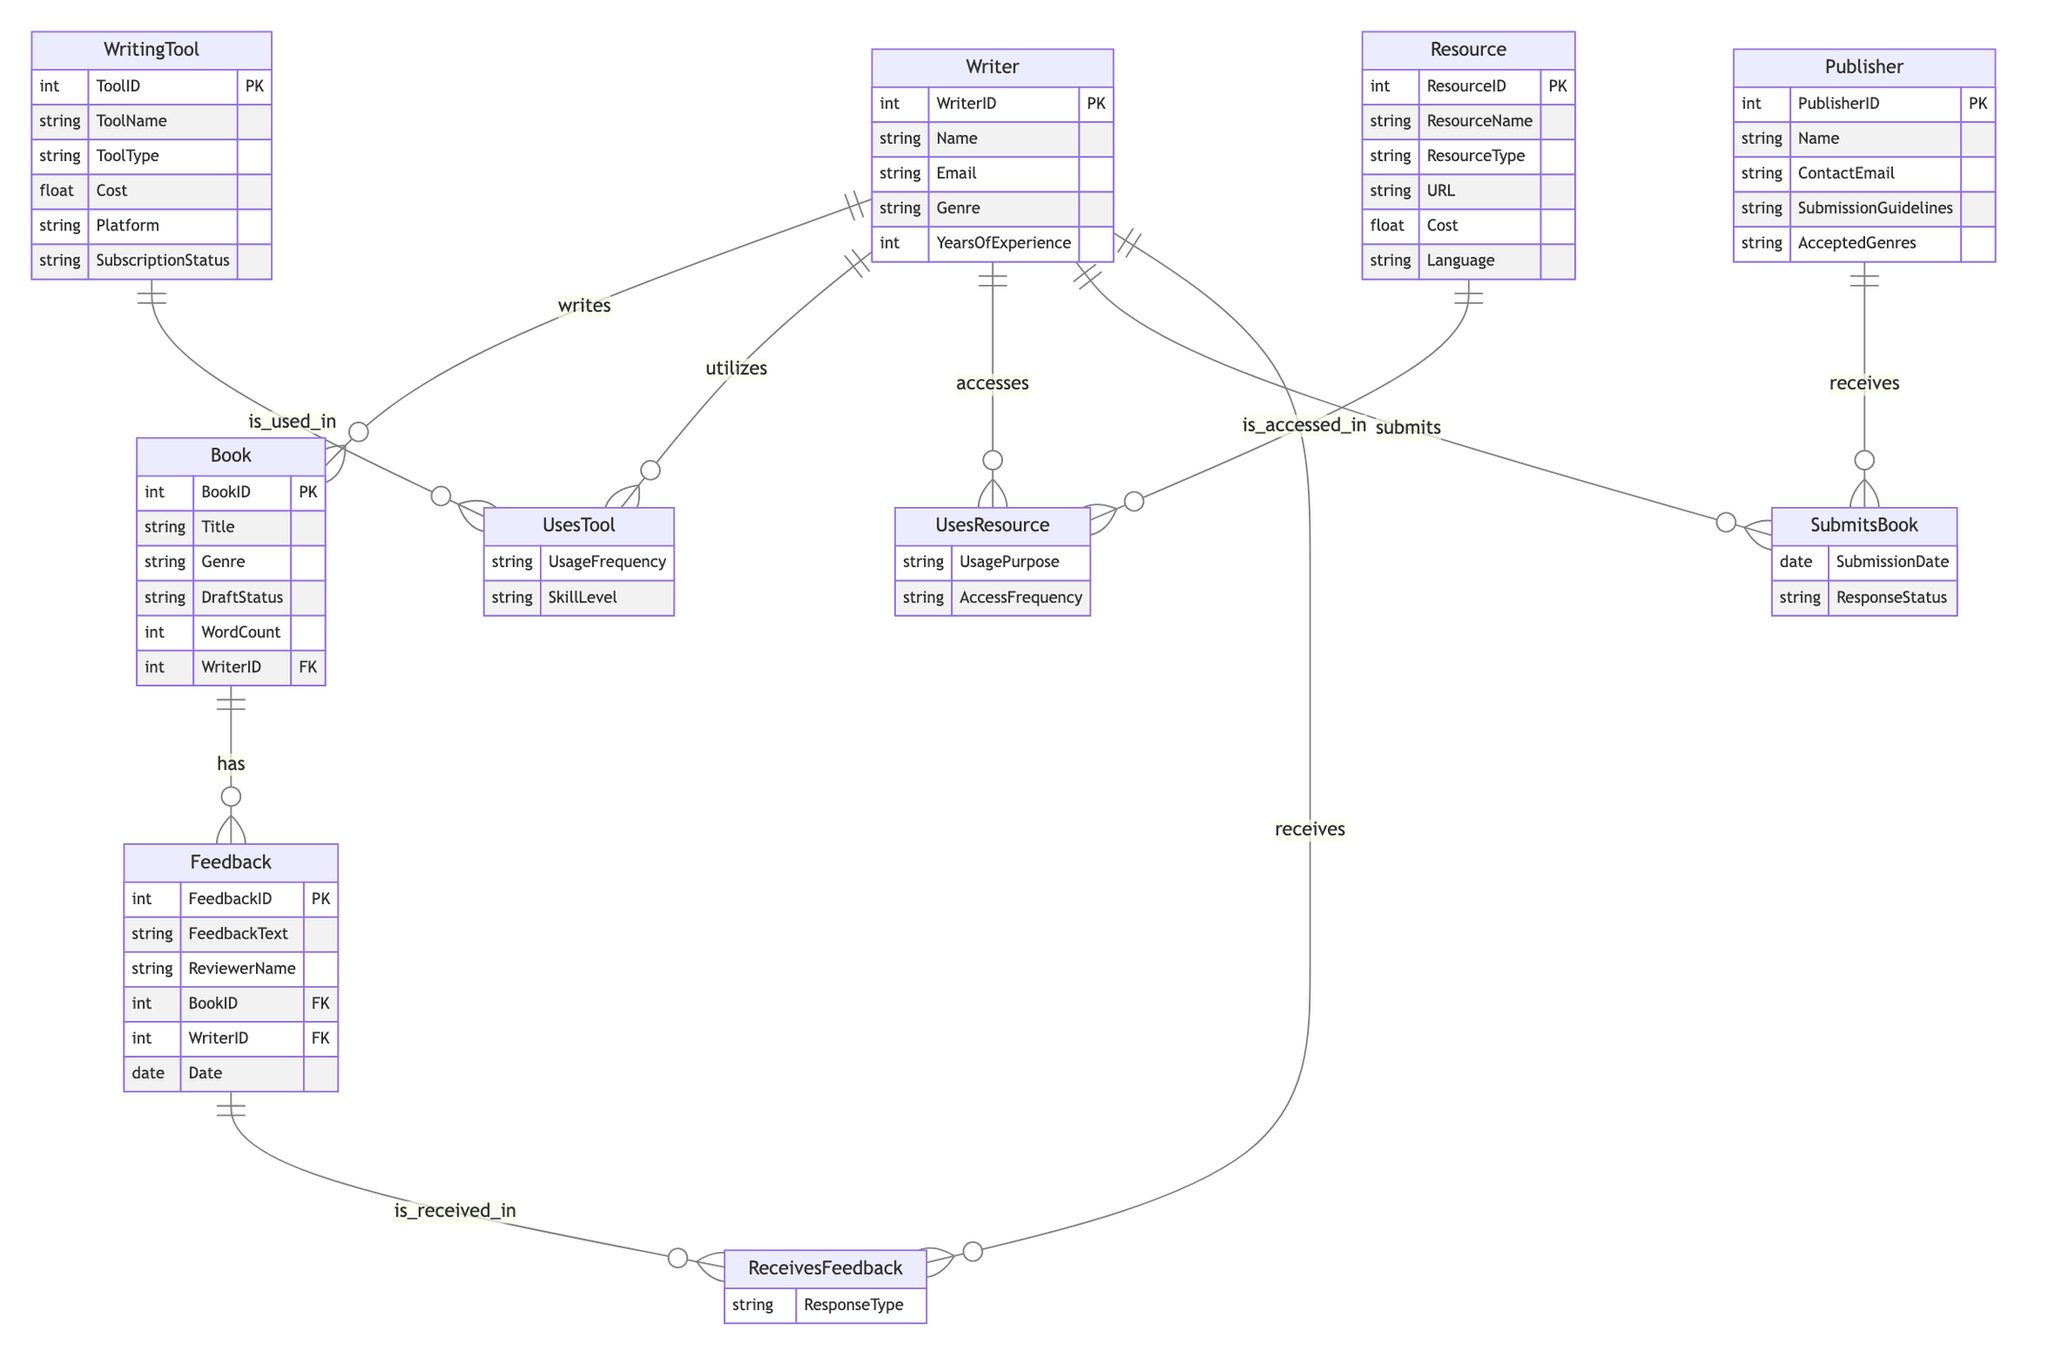What is the primary entity representing individuals who write? The diagram contains an entity labeled "Writer," which is defined as the primary individual responsible for creating works, such as books.
Answer: Writer How many attributes does the Book entity have? The Book entity is defined with six attributes: BookID, Title, Genre, DraftStatus, WordCount, and WriterID.
Answer: 6 What relationship connects Writer and Book? According to the diagram, the relationship connecting the Writer and the Book is labeled "writes." This indicates that a Writer creates or authors a Book.
Answer: writes What is the tool type for the WritingTool entity? The WritingTool entity has an attribute called ToolType, which specifies the category of the writing tool utilized by the Writer.
Answer: ToolType Which feedback is associated with the Book entity? The diagram shows that the Feedback entity is related to the Book entity through a relationship labeled "has," indicating that each Book can have multiple Feedback entries associated with it.
Answer: has What is the attribute that captures the Writer's experience? Among the attributes of the Writer entity, there is one labeled YearsOfExperience, which indicates how long the Writer has been engaging in writing practices.
Answer: YearsOfExperience How is the relationship between Writer and Publisher identified? The relationship between the Writer and the Publisher is identified as "submits," which signifies the act of a Writer submitting their work to a Publisher for consideration.
Answer: submits What attributes does the UsesTool relationship have? The UsesTool relationship between Writer and WritingTool includes two attributes: UsageFrequency and SkillLevel, detailing how often the tool is utilized and the Writer's proficiency with it.
Answer: UsageFrequency, SkillLevel What type of resource does the Resource entity capture? The Resource entity has an attribute named ResourceType that classifies the nature of the resources used by Writers, such as articles, books, websites, etc.
Answer: ResourceType 